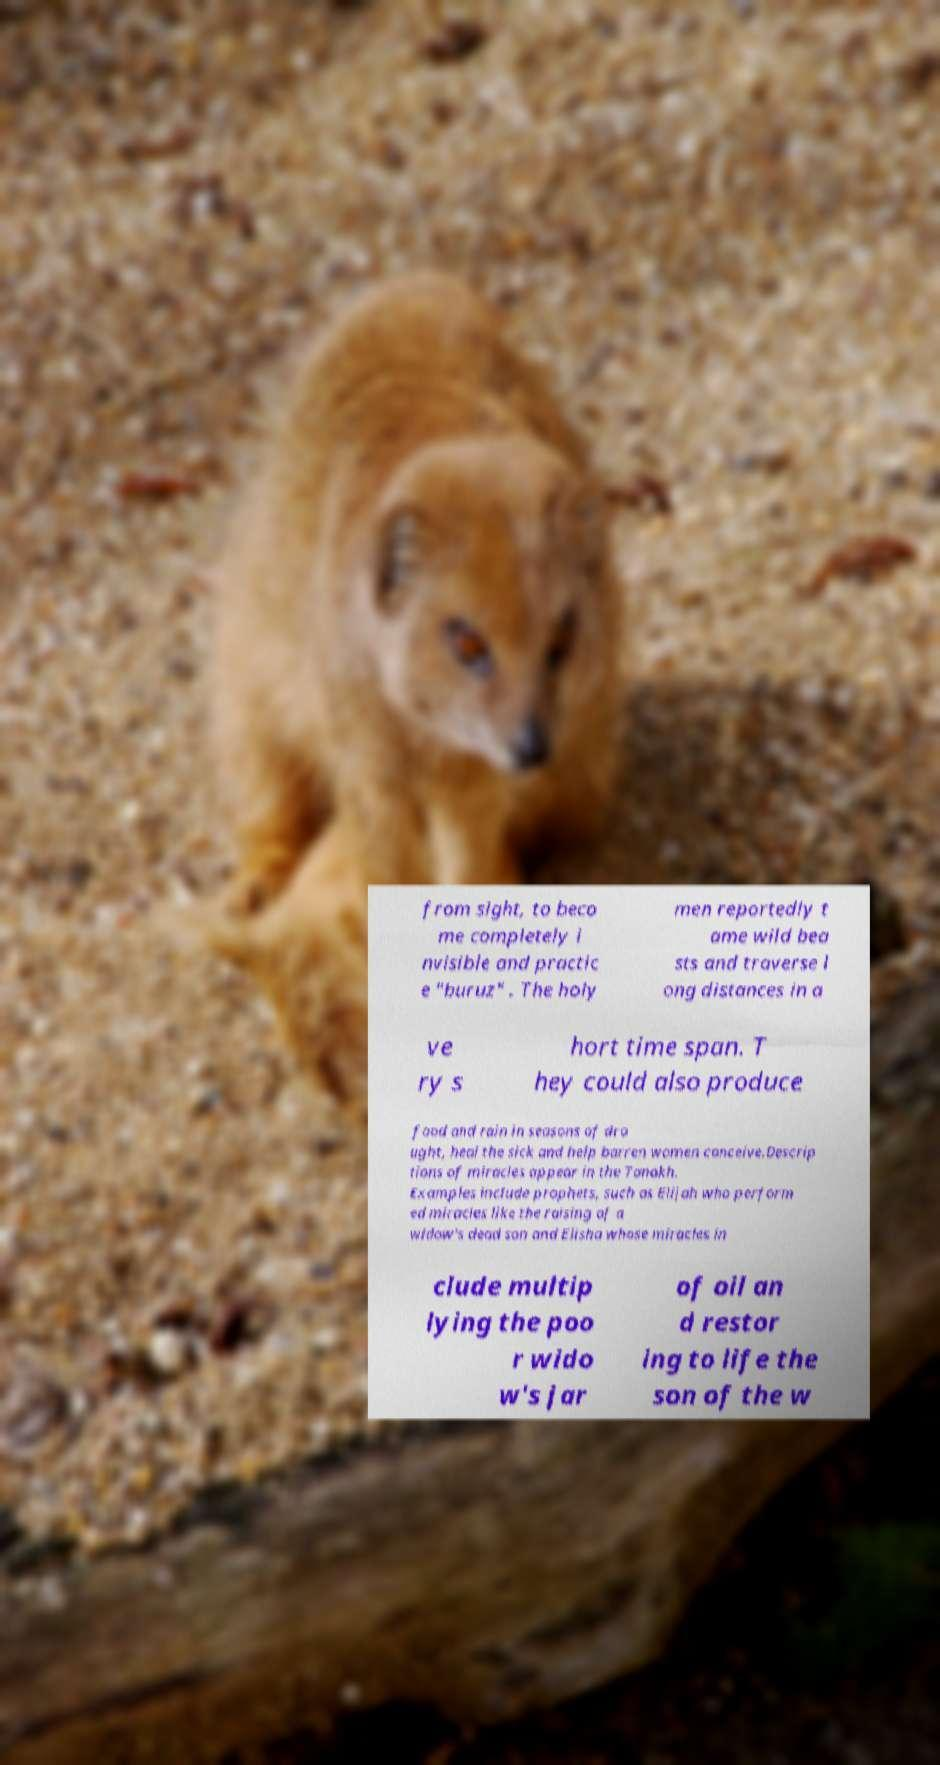There's text embedded in this image that I need extracted. Can you transcribe it verbatim? from sight, to beco me completely i nvisible and practic e "buruz" . The holy men reportedly t ame wild bea sts and traverse l ong distances in a ve ry s hort time span. T hey could also produce food and rain in seasons of dro ught, heal the sick and help barren women conceive.Descrip tions of miracles appear in the Tanakh. Examples include prophets, such as Elijah who perform ed miracles like the raising of a widow's dead son and Elisha whose miracles in clude multip lying the poo r wido w's jar of oil an d restor ing to life the son of the w 